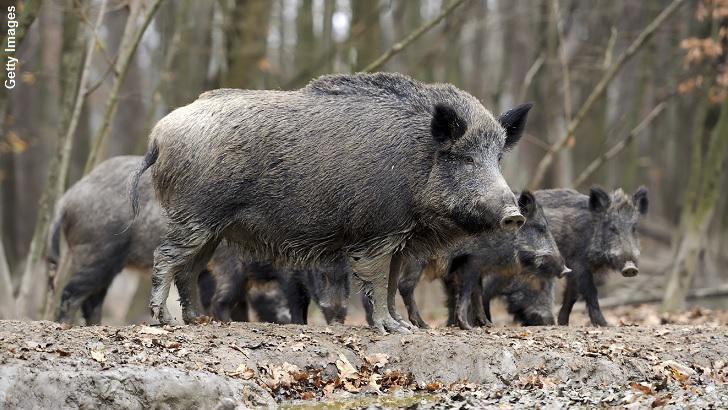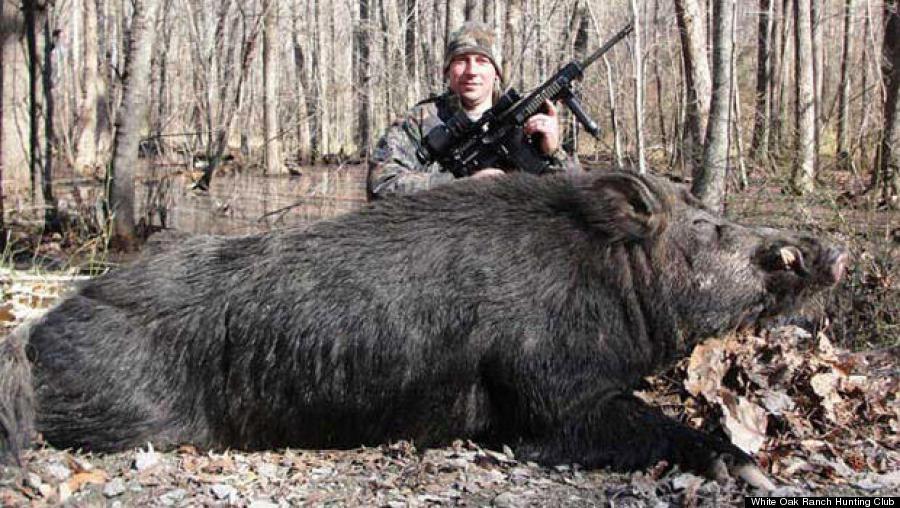The first image is the image on the left, the second image is the image on the right. Considering the images on both sides, is "A wild boar is lying on the ground in the image on the right." valid? Answer yes or no. Yes. The first image is the image on the left, the second image is the image on the right. Evaluate the accuracy of this statement regarding the images: "The combined images contain only standing pigs, including at least three lighter-colored piglets and at least three bigger adult pigs.". Is it true? Answer yes or no. No. 